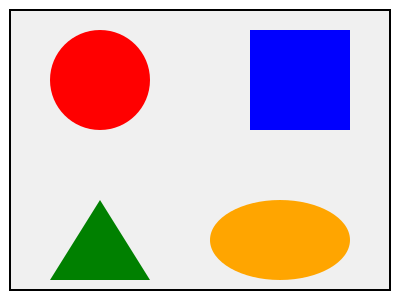Match the following 3D shapes to their corresponding conservative political party logos: sphere (red), cube (blue), pyramid (green), and ellipsoid (orange). Which shape represents the logo of the party known for its strong stance on traditional family values and limited government intervention? To answer this question, we need to consider the symbolism and values associated with conservative political parties:

1. Sphere (red): Often represents unity and globalism, which may not align with conservative values.
2. Cube (blue): Symbolizes stability and structure, which can be associated with conservative principles.
3. Pyramid (green): Represents hierarchy and tradition, aligning with conservative values.
4. Ellipsoid (orange): May represent flexibility or dynamism, which is less common in conservative imagery.

Conservative parties known for strong stances on traditional family values and limited government intervention often use symbols that represent stability, tradition, and hierarchy. Among the given shapes, the pyramid (green) best embodies these qualities. Its triangular structure suggests a hierarchical system and traditional values, which align closely with the described conservative party's principles.
Answer: Pyramid (green) 